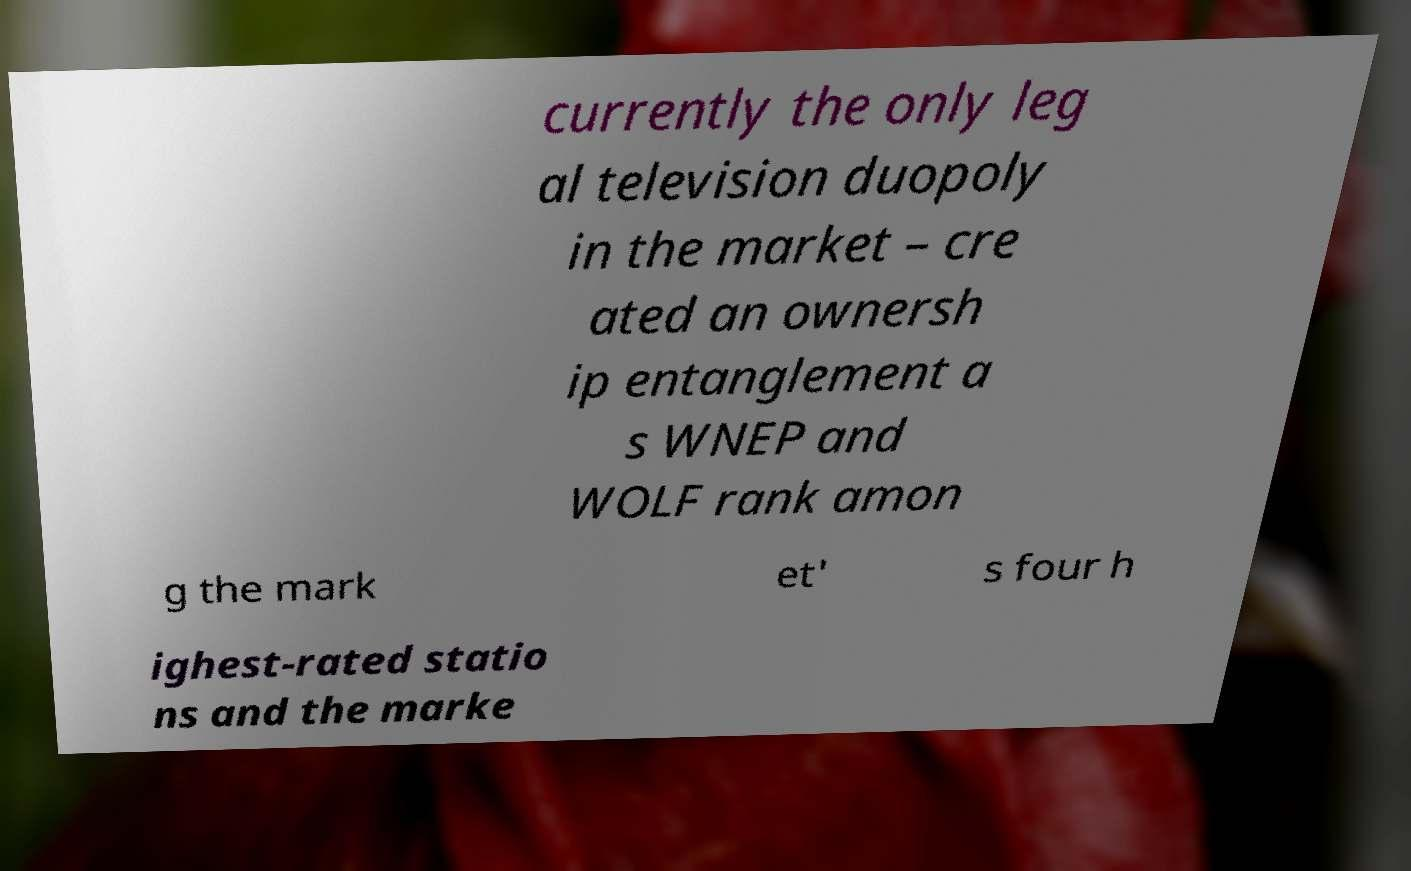Could you assist in decoding the text presented in this image and type it out clearly? currently the only leg al television duopoly in the market – cre ated an ownersh ip entanglement a s WNEP and WOLF rank amon g the mark et' s four h ighest-rated statio ns and the marke 